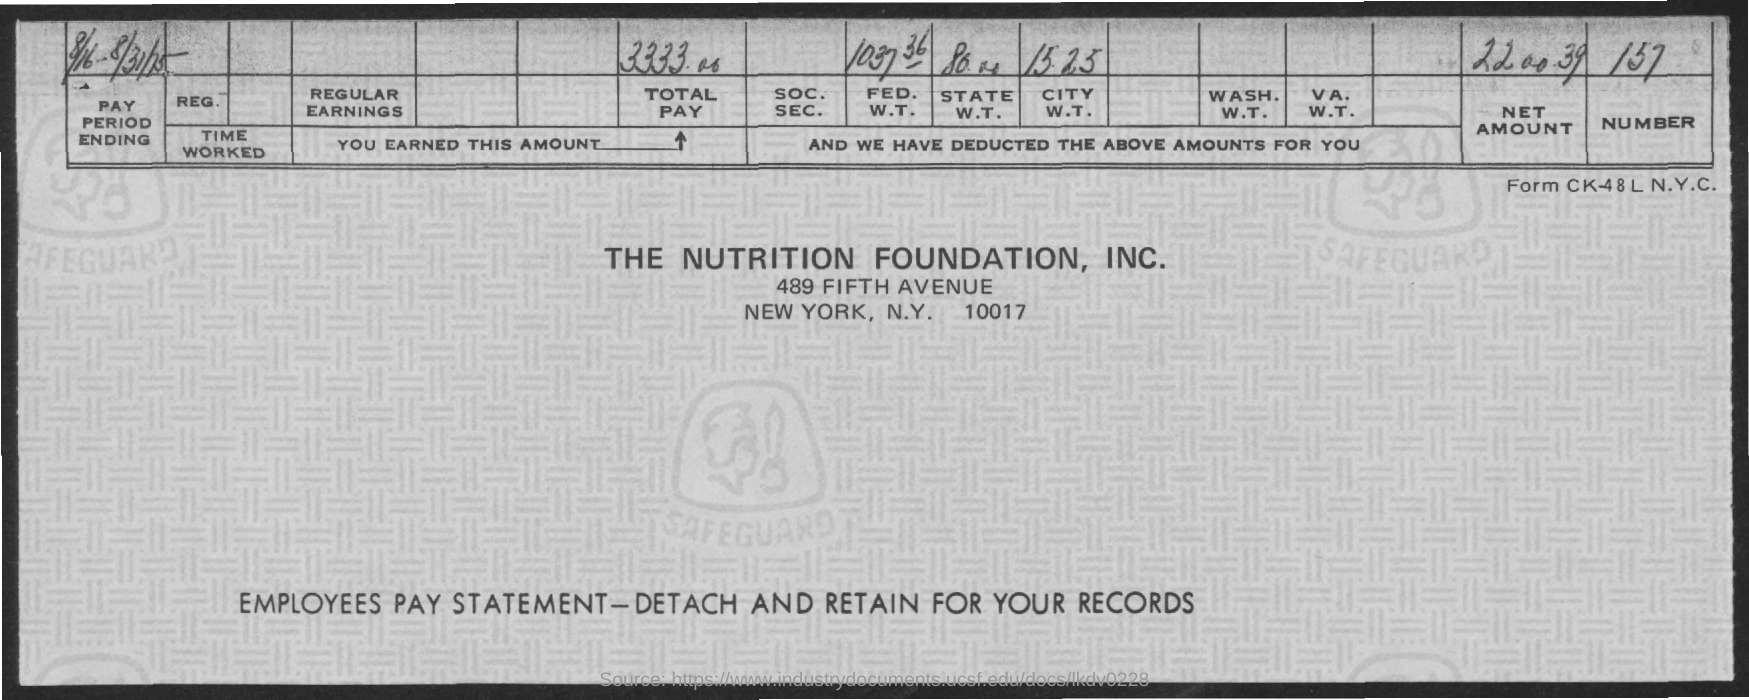Specify some key components in this picture. The number given is 157. The total amount paid by this company is 3333.00. 